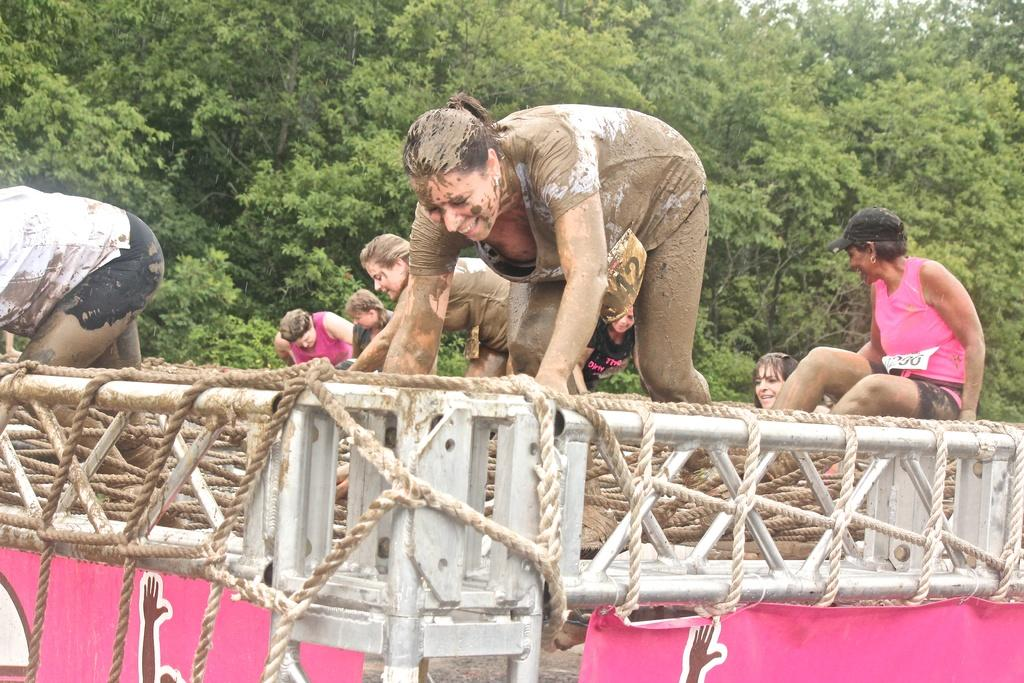What is the woman doing in the image? The woman is walking on ropes in the image. How are the ropes connected in the image? The ropes are tied to an iron frame. What is written or depicted on the banner at the bottom of the image? The content of the banner is not mentioned in the provided facts, so we cannot answer this question. What can be seen in the background of the image? There are trees in the background of the image. How does the woman use the flame to perform her act in the image? There is no mention of a flame in the image, so we cannot answer this question. 